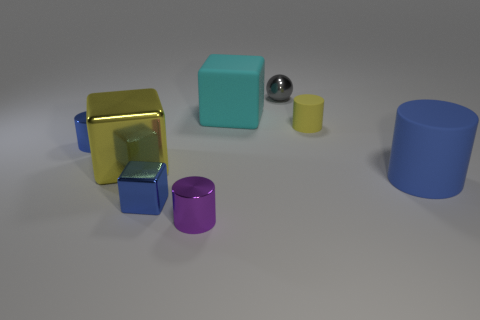Subtract all large blue matte cylinders. How many cylinders are left? 3 Subtract all green balls. How many blue cylinders are left? 2 Add 1 cyan rubber cylinders. How many objects exist? 9 Subtract all blue cylinders. How many cylinders are left? 2 Subtract 0 purple balls. How many objects are left? 8 Subtract all spheres. How many objects are left? 7 Subtract 1 balls. How many balls are left? 0 Subtract all green cylinders. Subtract all brown spheres. How many cylinders are left? 4 Subtract all blocks. Subtract all matte blocks. How many objects are left? 4 Add 8 tiny shiny cylinders. How many tiny shiny cylinders are left? 10 